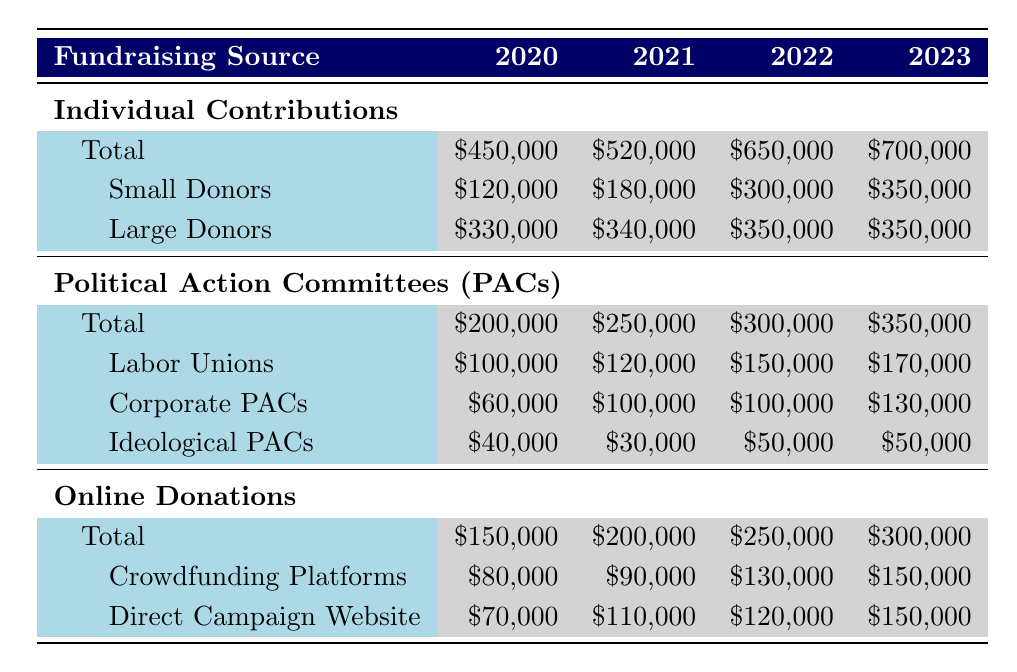What was the total amount raised from Individual Contributions in 2022? The table shows that in 2022, the total amount raised from Individual Contributions is \$650,000.
Answer: 650000 What percentage of the total Online Donations in 2023 came from Crowdfunding Platforms? The total amount raised from Online Donations in 2023 is \$300,000 and the amount from Crowdfunding Platforms is \$150,000. To find the percentage: (150,000 / 300,000) * 100 = 50%.
Answer: 50% Did the total amount from Political Action Committees (PACs) increase every year from 2020 to 2023? The table lists the total amounts for PACs: \$200,000 in 2020, \$250,000 in 2021, \$300,000 in 2022, and \$350,000 in 2023. Since all values increase from one year to the next, the answer is yes.
Answer: Yes Which year had the highest amount raised from Large Donors? In the table, the amount raised from Large Donors in each year is as follows: \$330,000 in 2020, \$340,000 in 2021, \$350,000 in 2022, and \$350,000 in 2023. The highest amount is \$350,000, which occurred in both 2022 and 2023.
Answer: 2022 and 2023 What is the total increase in contributions from Small Donors from 2020 to 2023? The table states that Small Donors contributed \$120,000 in 2020 and \$350,000 in 2023. The increase is calculated as \$350,000 - \$120,000 = \$230,000.
Answer: 230000 What was the difference in total PAC contributions between 2021 and 2022? The total PAC contributions were \$250,000 in 2021 and \$300,000 in 2022. The difference is \$300,000 - \$250,000 = \$50,000.
Answer: 50000 In which fundraising category did Tammy Baldwin receive the most contributions in 2022? The categories and their totals in 2022 are as follows: Individual Contributions \$650,000, PACs \$300,000, and Online Donations \$250,000. Individual Contributions were the highest at \$650,000.
Answer: Individual Contributions Was the total amount from Corporate PACs higher in 2023 than in 2020? According to the table, Corporate PACs contributed \$60,000 in 2020 and \$130,000 in 2023. Since \$130,000 is greater than \$60,000, the answer is yes.
Answer: Yes 